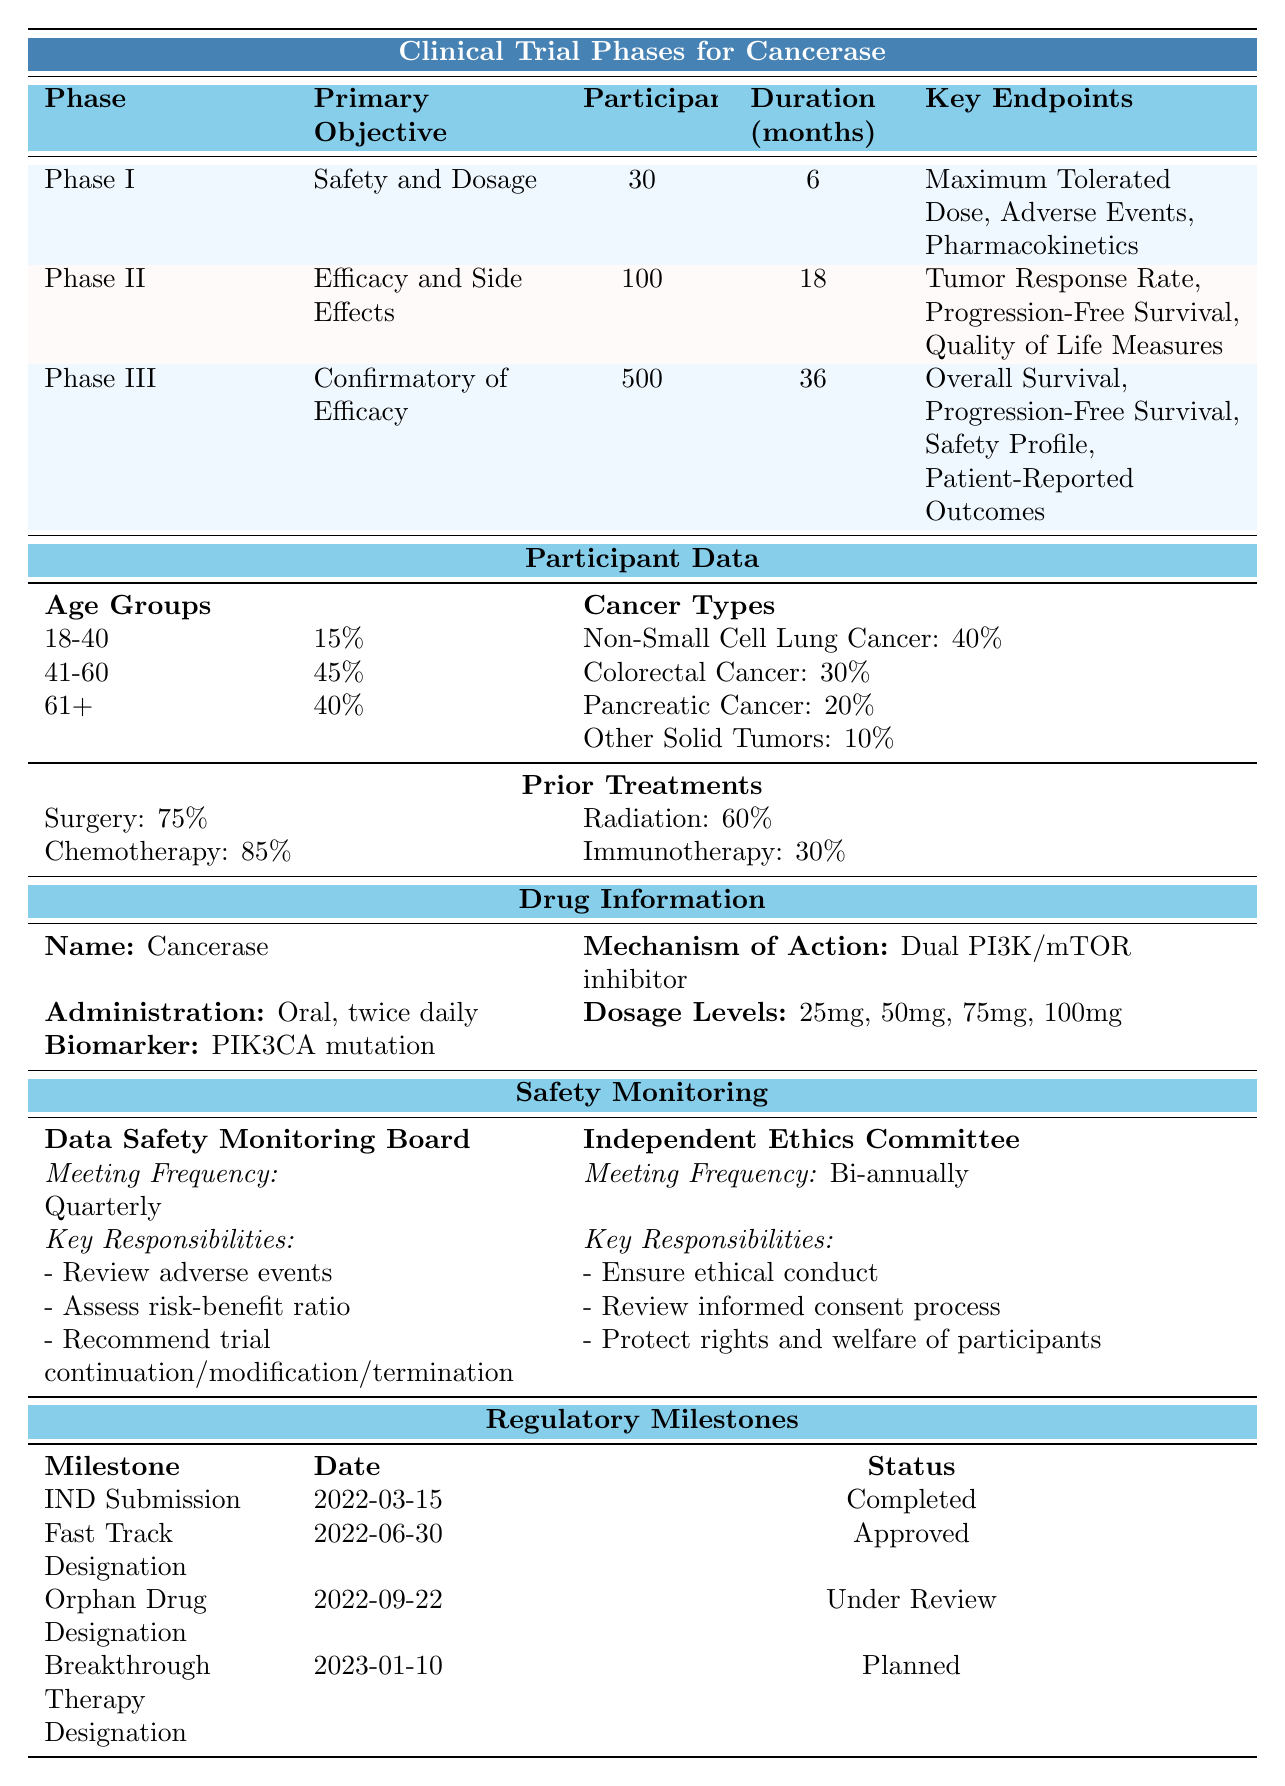What is the primary objective of Phase II? The table indicates that the primary objective of Phase II is "Efficacy and Side Effects."
Answer: Efficacy and Side Effects How long is the duration of Phase III trials? Phase III trials last for 36 months, as stated in the duration column of the Phase III row.
Answer: 36 months What percentage of participants have undergone chemotherapy? According to the table, 85% of participants have undergone chemotherapy.
Answer: 85% What is the total number of participants across all trial phases? Summing the participants from all phases: 30 (Phase I) + 100 (Phase II) + 500 (Phase III) = 630 participants total.
Answer: 630 Is the mechanism of action for Cancerase a single target inhibitor? The table specifies that the mechanism of action is a "Dual PI3K/mTOR inhibitor," indicating it targets two pathways rather than one.
Answer: No How many participants are in the age group 61 and above? From the table, the percentage of participants aged 61 and above is 40%, but since we cannot calculate the number of participants without total participants (630), we can say it's 40% of 630. 0.40 * 630 = 252 participants.
Answer: 252 participants What are the key responsibilities of the Data Safety Monitoring Board? The table lists three key responsibilities: review adverse events, assess risk-benefit ratio, and recommend trial continuation/modification/termination.
Answer: Review adverse events, assess risk-benefit ratio, recommend trial continuation/modification/termination What percentage represents the most common age group among participants? The most common age group is 41-60 with 45% of participants, which is the highest percentage in the Age Groups section.
Answer: 45% What was the status of the Orphan Drug Designation milestone? The table indicates that the status of the Orphan Drug Designation milestone is "Under Review."
Answer: Under Review Based on participant data, which cancer type has the least representation? According to the table, "Other Solid Tumors" has the least representation at 10%, which is the lowest percentage among the cancer type distributions.
Answer: Other Solid Tumors 